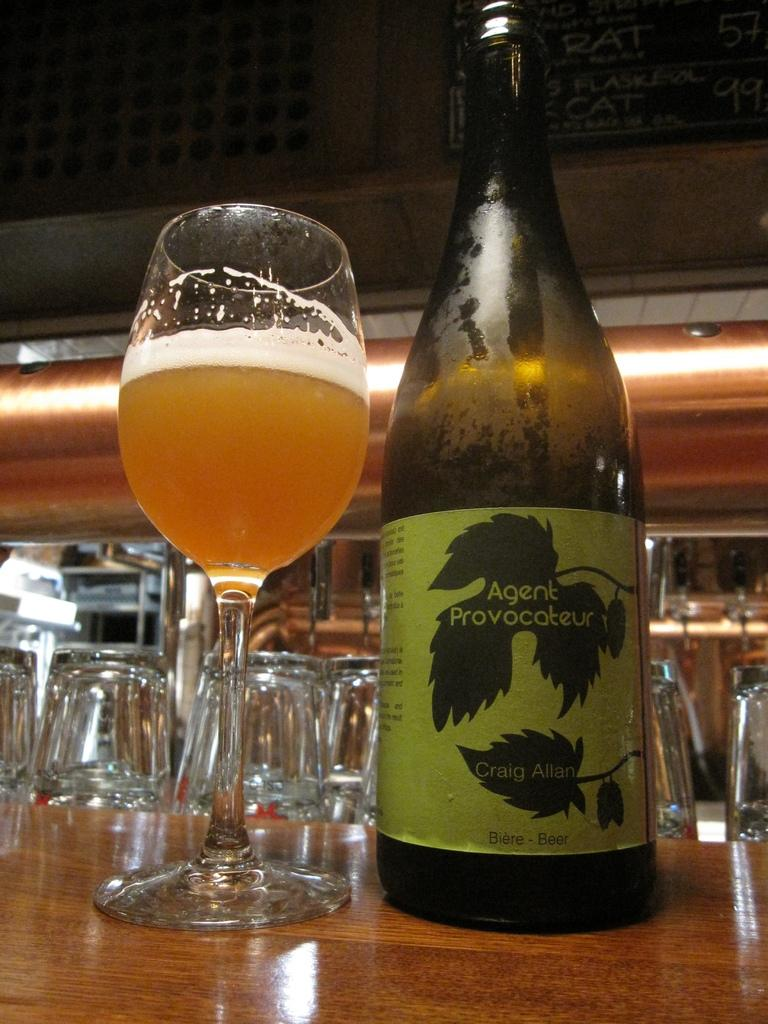<image>
Give a short and clear explanation of the subsequent image. a bottle of Agent Provocateur beer is poured into the glass 